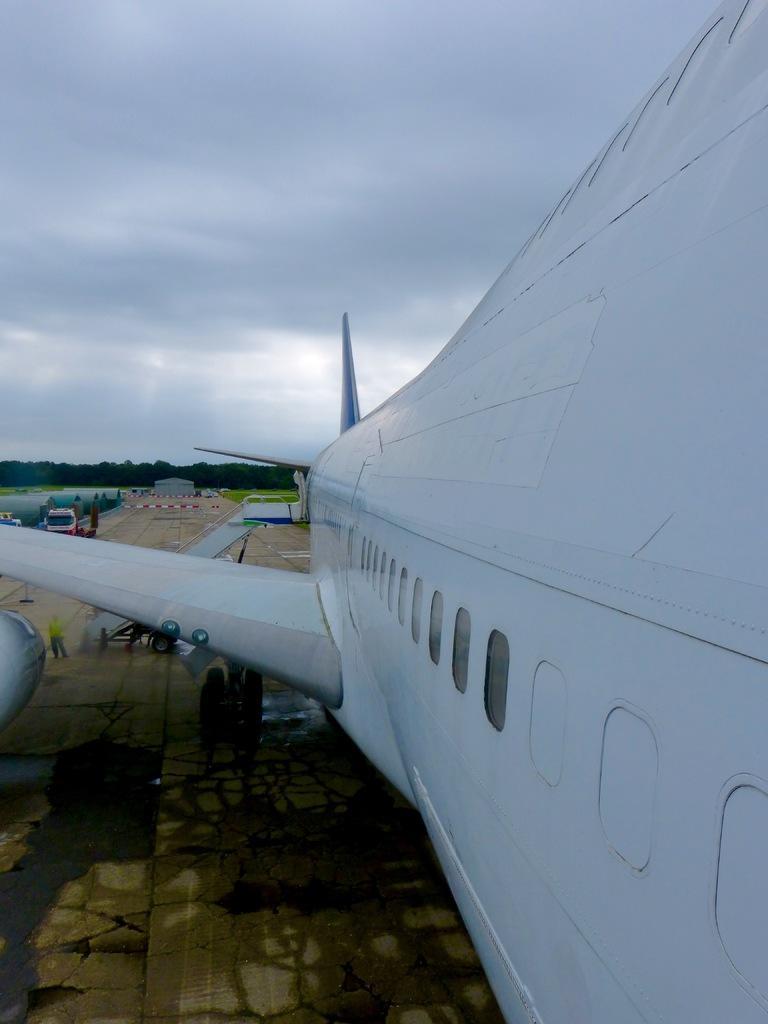In one or two sentences, can you explain what this image depicts? In this picture there is an aeroplane on the right side of the image and there are other vehicles on the left side of the image, there are trees in the center of the image. 